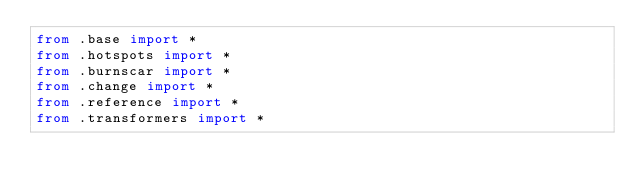<code> <loc_0><loc_0><loc_500><loc_500><_Python_>from .base import *
from .hotspots import *
from .burnscar import *
from .change import *
from .reference import *
from .transformers import *
</code> 